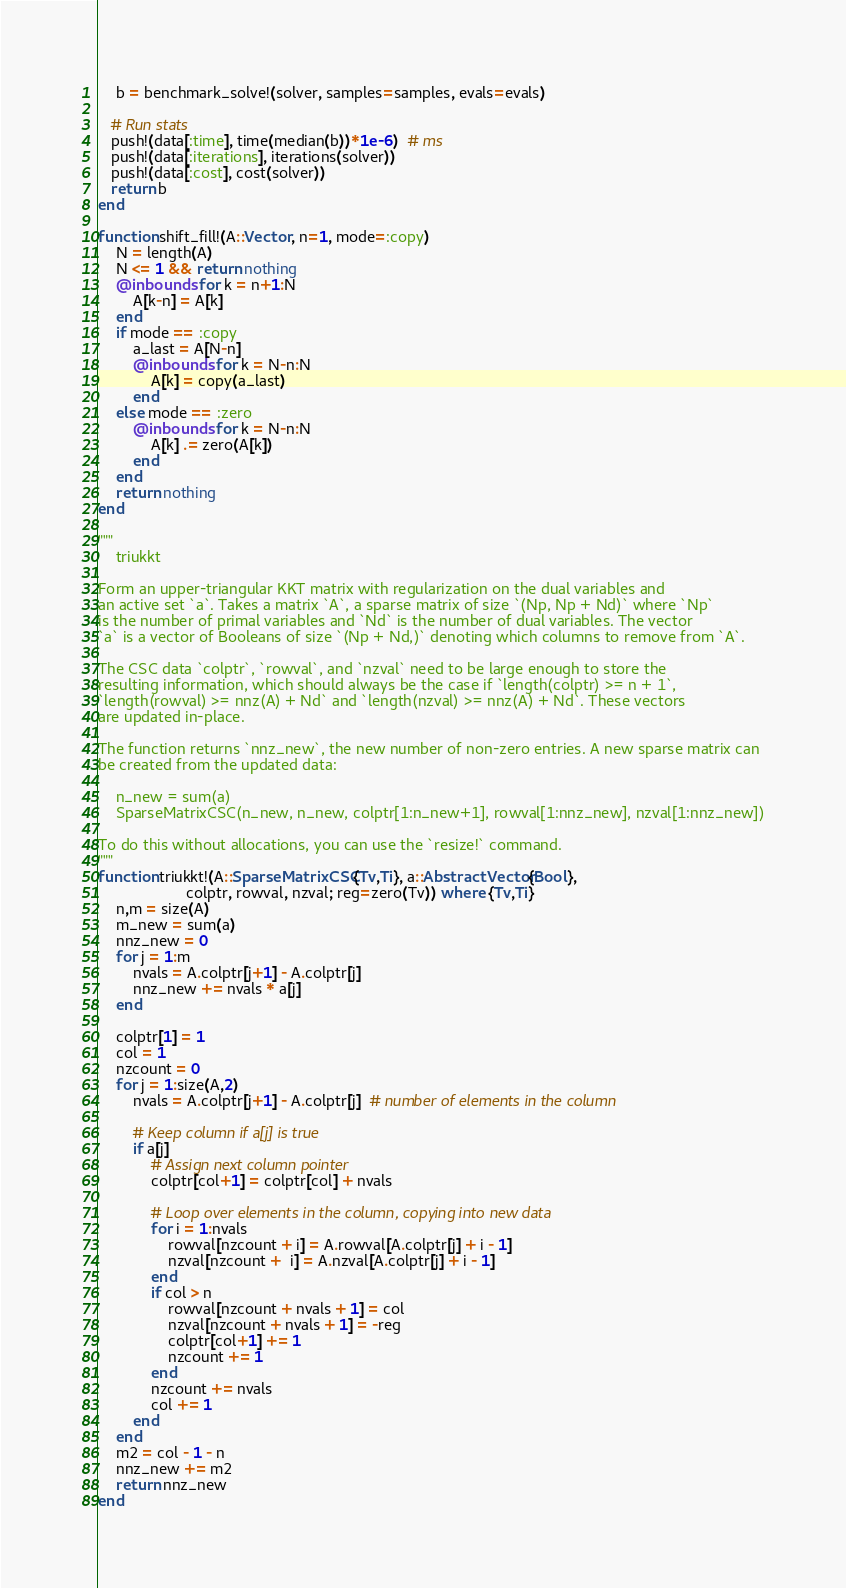Convert code to text. <code><loc_0><loc_0><loc_500><loc_500><_Julia_>	b = benchmark_solve!(solver, samples=samples, evals=evals)

   # Run stats
   push!(data[:time], time(median(b))*1e-6)  # ms
   push!(data[:iterations], iterations(solver))
   push!(data[:cost], cost(solver))
   return b
end

function shift_fill!(A::Vector, n=1, mode=:copy)
    N = length(A)
    N <= 1 && return nothing
	@inbounds for k = n+1:N
		A[k-n] = A[k]
    end
    if mode == :copy
        a_last = A[N-n]
        @inbounds for k = N-n:N
            A[k] = copy(a_last)
        end
    else mode == :zero
        @inbounds for k = N-n:N
            A[k] .= zero(A[k])
        end
    end
	return nothing
end

"""
    triukkt

Form an upper-triangular KKT matrix with regularization on the dual variables and 
an active set `a`. Takes a matrix `A`, a sparse matrix of size `(Np, Np + Nd)` where `Np` 
is the number of primal variables and `Nd` is the number of dual variables. The vector 
`a` is a vector of Booleans of size `(Np + Nd,)` denoting which columns to remove from `A`.

The CSC data `colptr`, `rowval`, and `nzval` need to be large enough to store the 
resulting information, which should always be the case if `length(colptr) >= n + 1`, 
`length(rowval) >= nnz(A) + Nd` and `length(nzval) >= nnz(A) + Nd`. These vectors 
are updated in-place.

The function returns `nnz_new`, the new number of non-zero entries. A new sparse matrix can 
be created from the updated data:

    n_new = sum(a)
    SparseMatrixCSC(n_new, n_new, colptr[1:n_new+1], rowval[1:nnz_new], nzval[1:nnz_new])

To do this without allocations, you can use the `resize!` command.
"""
function triukkt!(A::SparseMatrixCSC{Tv,Ti}, a::AbstractVector{Bool},
                    colptr, rowval, nzval; reg=zero(Tv)) where {Tv,Ti}
    n,m = size(A)
    m_new = sum(a)
    nnz_new = 0
    for j = 1:m
        nvals = A.colptr[j+1] - A.colptr[j]
        nnz_new += nvals * a[j]
    end

    colptr[1] = 1
    col = 1
    nzcount = 0
    for j = 1:size(A,2)
        nvals = A.colptr[j+1] - A.colptr[j]  # number of elements in the column

        # Keep column if a[j] is true
        if a[j]  
            # Assign next column pointer 
            colptr[col+1] = colptr[col] + nvals

            # Loop over elements in the column, copying into new data
            for i = 1:nvals
                rowval[nzcount + i] = A.rowval[A.colptr[j] + i - 1]
                nzval[nzcount +  i] = A.nzval[A.colptr[j] + i - 1]
            end
            if col > n
                rowval[nzcount + nvals + 1] = col
                nzval[nzcount + nvals + 1] = -reg
                colptr[col+1] += 1
                nzcount += 1
            end
            nzcount += nvals
            col += 1
        end
    end
    m2 = col - 1 - n
    nnz_new += m2
    return nnz_new
end</code> 